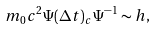Convert formula to latex. <formula><loc_0><loc_0><loc_500><loc_500>m _ { 0 } c ^ { 2 } \Psi ( \Delta t ) _ { c } \Psi ^ { - 1 } \sim h ,</formula> 